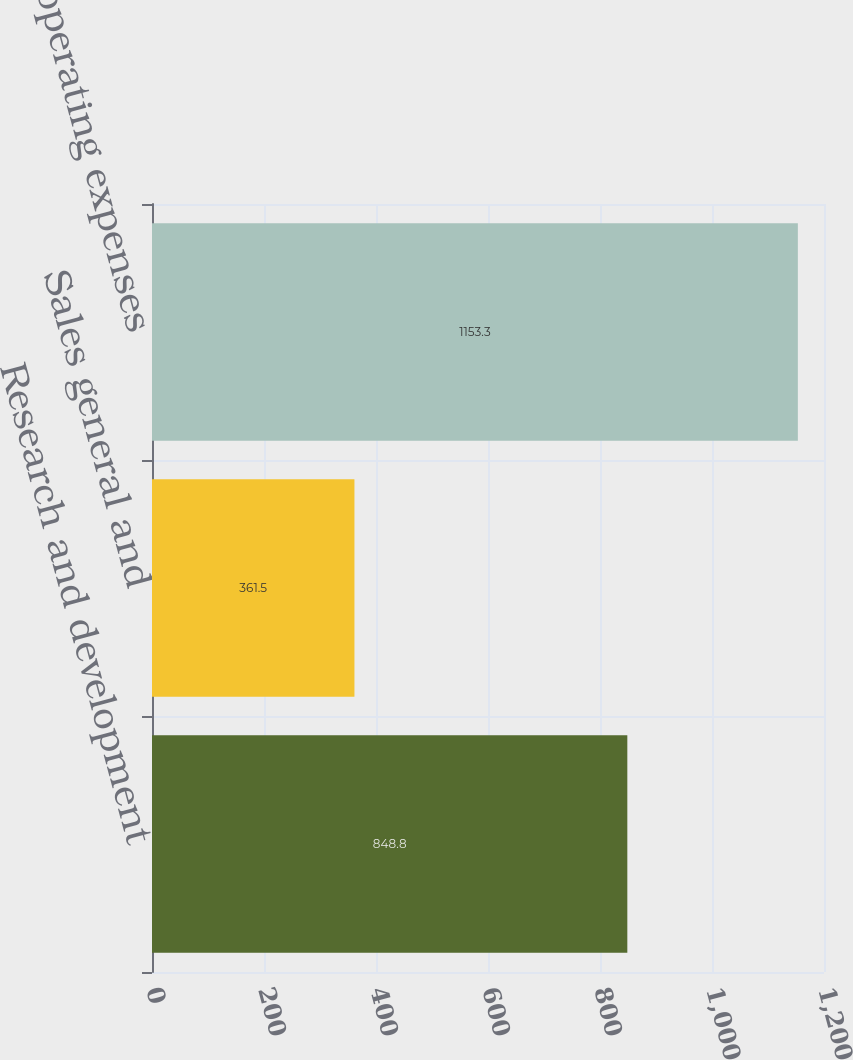<chart> <loc_0><loc_0><loc_500><loc_500><bar_chart><fcel>Research and development<fcel>Sales general and<fcel>Total operating expenses<nl><fcel>848.8<fcel>361.5<fcel>1153.3<nl></chart> 